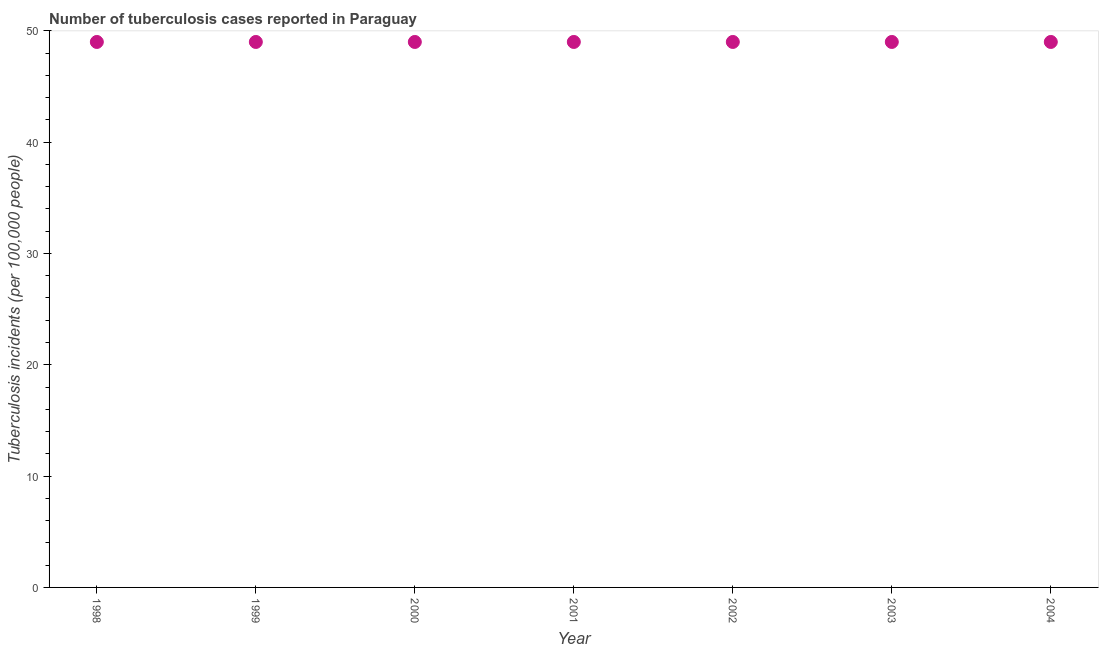What is the number of tuberculosis incidents in 1999?
Offer a very short reply. 49. Across all years, what is the maximum number of tuberculosis incidents?
Your answer should be very brief. 49. Across all years, what is the minimum number of tuberculosis incidents?
Your response must be concise. 49. In which year was the number of tuberculosis incidents minimum?
Your response must be concise. 1998. What is the sum of the number of tuberculosis incidents?
Make the answer very short. 343. What is the difference between the number of tuberculosis incidents in 1998 and 2000?
Ensure brevity in your answer.  0. What is the difference between the highest and the second highest number of tuberculosis incidents?
Keep it short and to the point. 0. How many dotlines are there?
Offer a terse response. 1. How many years are there in the graph?
Offer a terse response. 7. What is the difference between two consecutive major ticks on the Y-axis?
Give a very brief answer. 10. Does the graph contain any zero values?
Give a very brief answer. No. Does the graph contain grids?
Your response must be concise. No. What is the title of the graph?
Ensure brevity in your answer.  Number of tuberculosis cases reported in Paraguay. What is the label or title of the X-axis?
Provide a succinct answer. Year. What is the label or title of the Y-axis?
Provide a succinct answer. Tuberculosis incidents (per 100,0 people). What is the Tuberculosis incidents (per 100,000 people) in 1998?
Offer a very short reply. 49. What is the Tuberculosis incidents (per 100,000 people) in 2002?
Make the answer very short. 49. What is the difference between the Tuberculosis incidents (per 100,000 people) in 1998 and 1999?
Give a very brief answer. 0. What is the difference between the Tuberculosis incidents (per 100,000 people) in 1998 and 2001?
Your answer should be very brief. 0. What is the difference between the Tuberculosis incidents (per 100,000 people) in 1999 and 2000?
Make the answer very short. 0. What is the difference between the Tuberculosis incidents (per 100,000 people) in 1999 and 2001?
Your answer should be very brief. 0. What is the difference between the Tuberculosis incidents (per 100,000 people) in 1999 and 2003?
Offer a terse response. 0. What is the difference between the Tuberculosis incidents (per 100,000 people) in 1999 and 2004?
Give a very brief answer. 0. What is the difference between the Tuberculosis incidents (per 100,000 people) in 2000 and 2004?
Your response must be concise. 0. What is the difference between the Tuberculosis incidents (per 100,000 people) in 2001 and 2004?
Offer a very short reply. 0. What is the difference between the Tuberculosis incidents (per 100,000 people) in 2002 and 2003?
Your answer should be compact. 0. What is the difference between the Tuberculosis incidents (per 100,000 people) in 2003 and 2004?
Provide a succinct answer. 0. What is the ratio of the Tuberculosis incidents (per 100,000 people) in 1998 to that in 1999?
Offer a very short reply. 1. What is the ratio of the Tuberculosis incidents (per 100,000 people) in 1998 to that in 2001?
Give a very brief answer. 1. What is the ratio of the Tuberculosis incidents (per 100,000 people) in 1998 to that in 2003?
Make the answer very short. 1. What is the ratio of the Tuberculosis incidents (per 100,000 people) in 1998 to that in 2004?
Keep it short and to the point. 1. What is the ratio of the Tuberculosis incidents (per 100,000 people) in 1999 to that in 2000?
Provide a succinct answer. 1. What is the ratio of the Tuberculosis incidents (per 100,000 people) in 1999 to that in 2002?
Provide a succinct answer. 1. What is the ratio of the Tuberculosis incidents (per 100,000 people) in 1999 to that in 2003?
Your answer should be compact. 1. What is the ratio of the Tuberculosis incidents (per 100,000 people) in 1999 to that in 2004?
Keep it short and to the point. 1. What is the ratio of the Tuberculosis incidents (per 100,000 people) in 2000 to that in 2001?
Give a very brief answer. 1. What is the ratio of the Tuberculosis incidents (per 100,000 people) in 2000 to that in 2002?
Offer a terse response. 1. What is the ratio of the Tuberculosis incidents (per 100,000 people) in 2000 to that in 2004?
Your response must be concise. 1. What is the ratio of the Tuberculosis incidents (per 100,000 people) in 2001 to that in 2004?
Make the answer very short. 1. What is the ratio of the Tuberculosis incidents (per 100,000 people) in 2002 to that in 2004?
Your answer should be very brief. 1. What is the ratio of the Tuberculosis incidents (per 100,000 people) in 2003 to that in 2004?
Your answer should be compact. 1. 